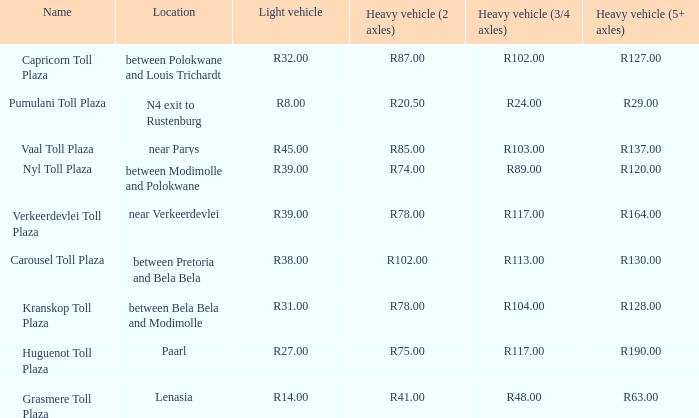I'm looking to parse the entire table for insights. Could you assist me with that? {'header': ['Name', 'Location', 'Light vehicle', 'Heavy vehicle (2 axles)', 'Heavy vehicle (3/4 axles)', 'Heavy vehicle (5+ axles)'], 'rows': [['Capricorn Toll Plaza', 'between Polokwane and Louis Trichardt', 'R32.00', 'R87.00', 'R102.00', 'R127.00'], ['Pumulani Toll Plaza', 'N4 exit to Rustenburg', 'R8.00', 'R20.50', 'R24.00', 'R29.00'], ['Vaal Toll Plaza', 'near Parys', 'R45.00', 'R85.00', 'R103.00', 'R137.00'], ['Nyl Toll Plaza', 'between Modimolle and Polokwane', 'R39.00', 'R74.00', 'R89.00', 'R120.00'], ['Verkeerdevlei Toll Plaza', 'near Verkeerdevlei', 'R39.00', 'R78.00', 'R117.00', 'R164.00'], ['Carousel Toll Plaza', 'between Pretoria and Bela Bela', 'R38.00', 'R102.00', 'R113.00', 'R130.00'], ['Kranskop Toll Plaza', 'between Bela Bela and Modimolle', 'R31.00', 'R78.00', 'R104.00', 'R128.00'], ['Huguenot Toll Plaza', 'Paarl', 'R27.00', 'R75.00', 'R117.00', 'R190.00'], ['Grasmere Toll Plaza', 'Lenasia', 'R14.00', 'R41.00', 'R48.00', 'R63.00']]} What is the toll for light vehicles at the plaza between bela bela and modimolle? R31.00. 